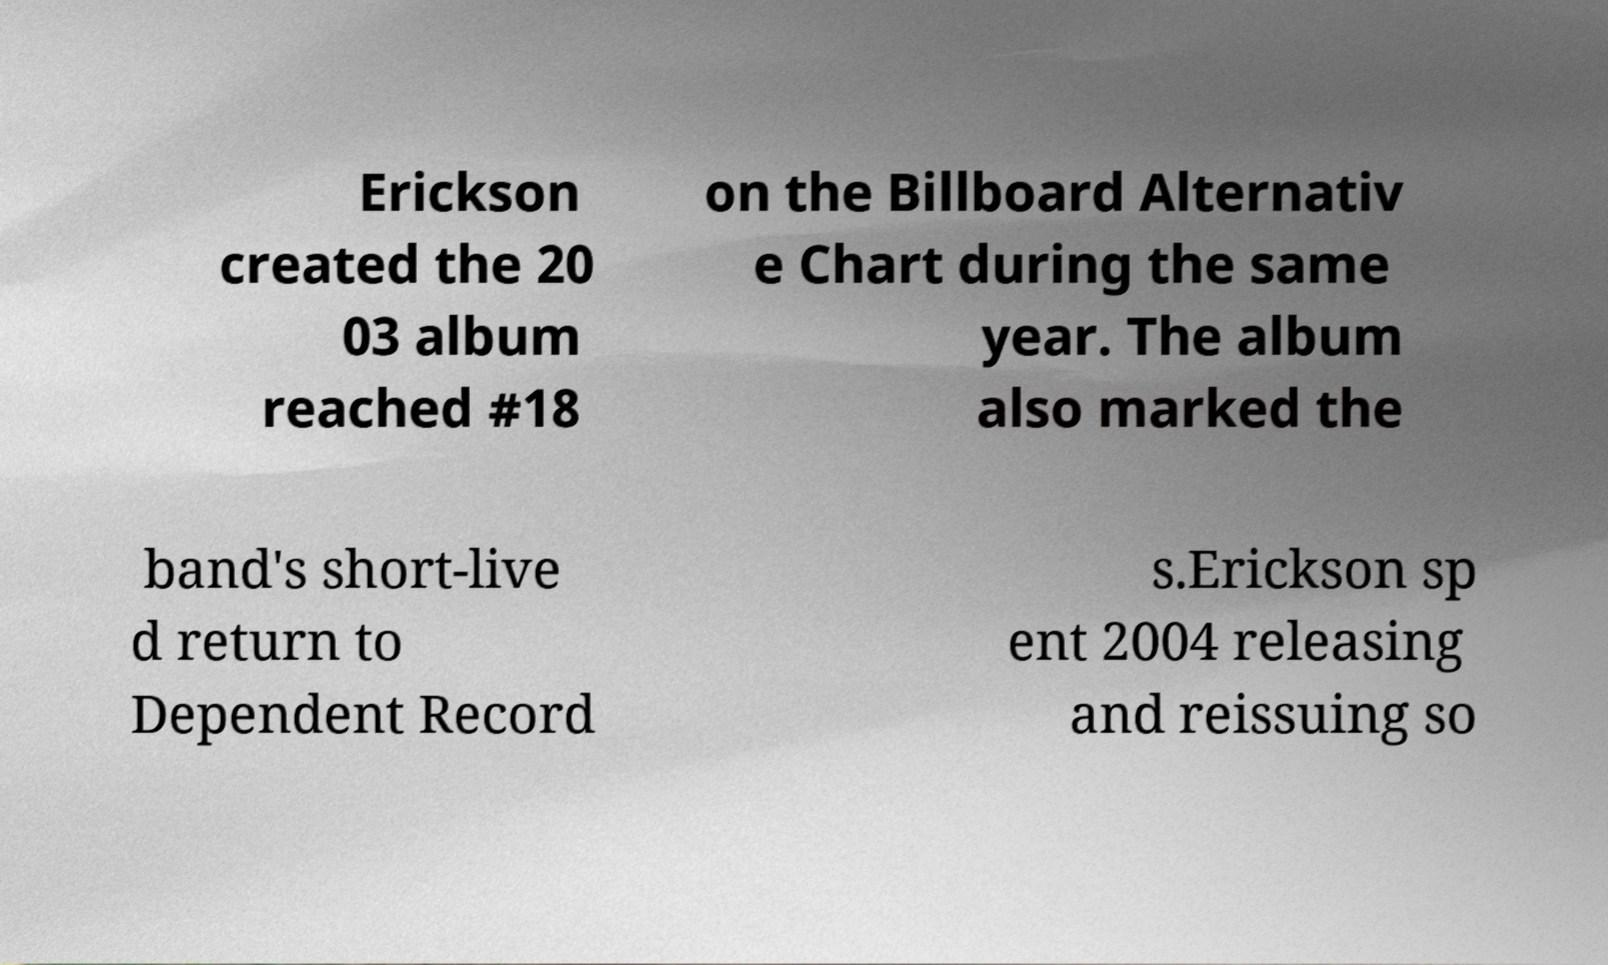Please identify and transcribe the text found in this image. Erickson created the 20 03 album reached #18 on the Billboard Alternativ e Chart during the same year. The album also marked the band's short-live d return to Dependent Record s.Erickson sp ent 2004 releasing and reissuing so 